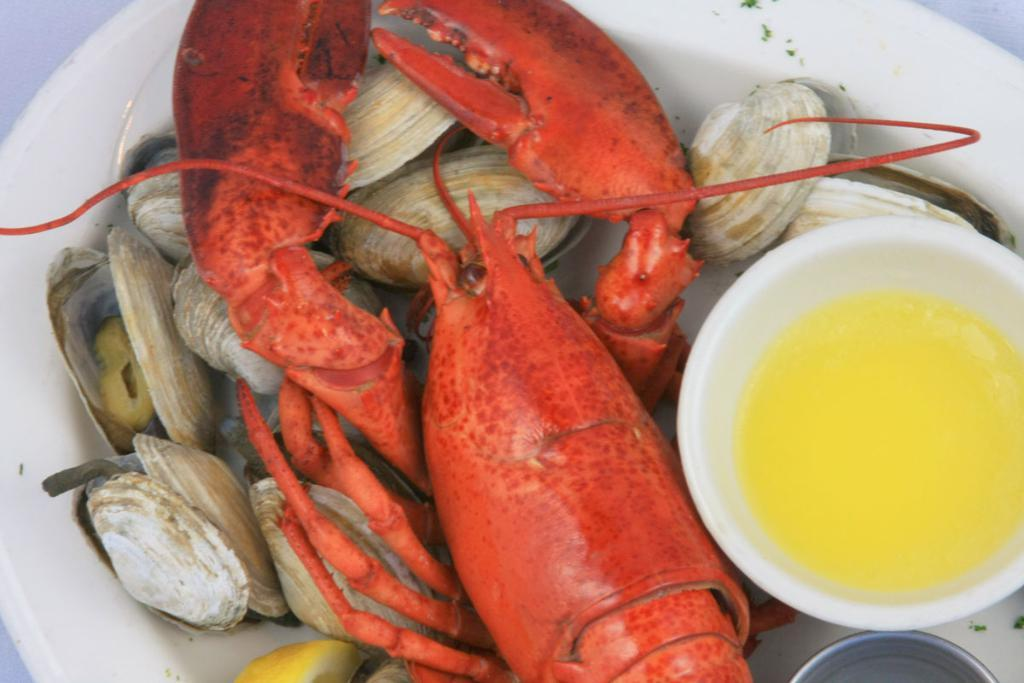What is on the plate in the image? There is food on a white color plate in the image. Can you describe the colors of the food? The food has orange, brown, and white colors. What else can be seen in the image besides the plate? There is a bowl in the image. What is inside the bowl? There is something in the bowl. What type of animal can be seen walking in the image? There is no animal present in the image, and therefore no such activity can be observed. Is there a pig in the image? There is no pig present in the image. 